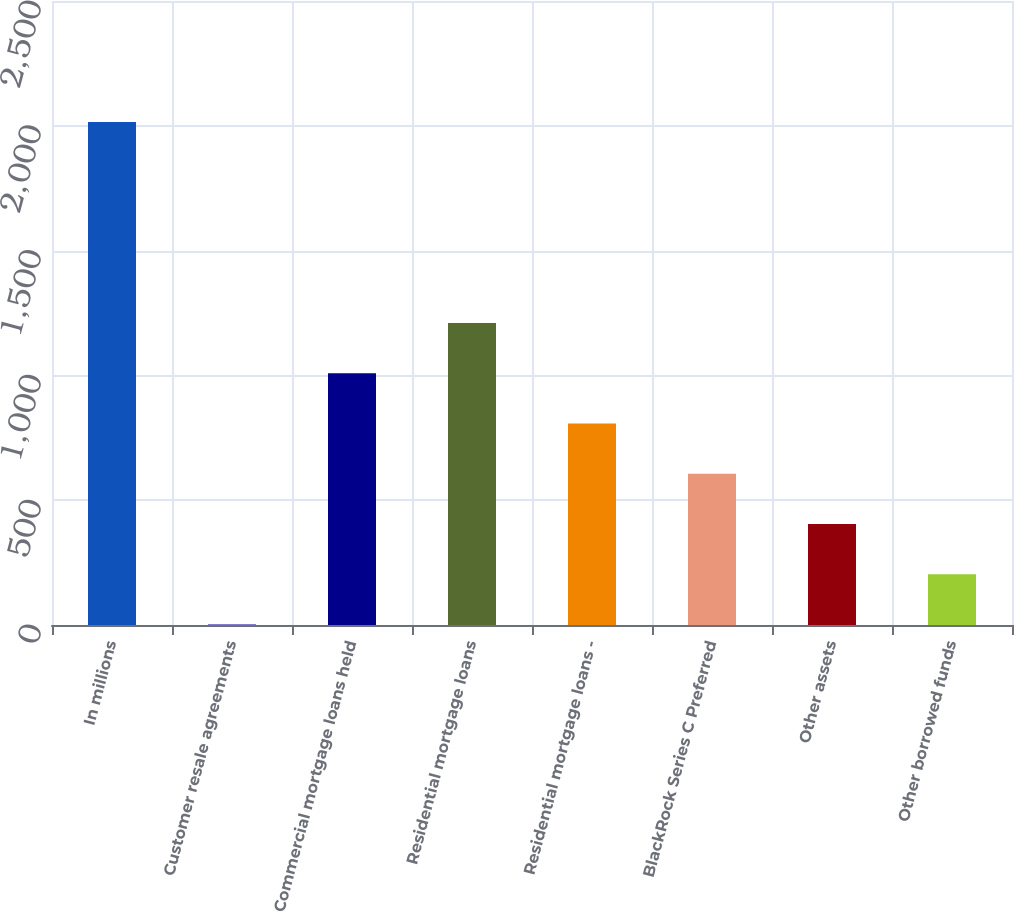<chart> <loc_0><loc_0><loc_500><loc_500><bar_chart><fcel>In millions<fcel>Customer resale agreements<fcel>Commercial mortgage loans held<fcel>Residential mortgage loans<fcel>Residential mortgage loans -<fcel>BlackRock Series C Preferred<fcel>Other assets<fcel>Other borrowed funds<nl><fcel>2015<fcel>2<fcel>1008.5<fcel>1209.8<fcel>807.2<fcel>605.9<fcel>404.6<fcel>203.3<nl></chart> 